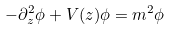Convert formula to latex. <formula><loc_0><loc_0><loc_500><loc_500>- \partial _ { z } ^ { 2 } \phi + V ( z ) \phi = m ^ { 2 } \phi</formula> 